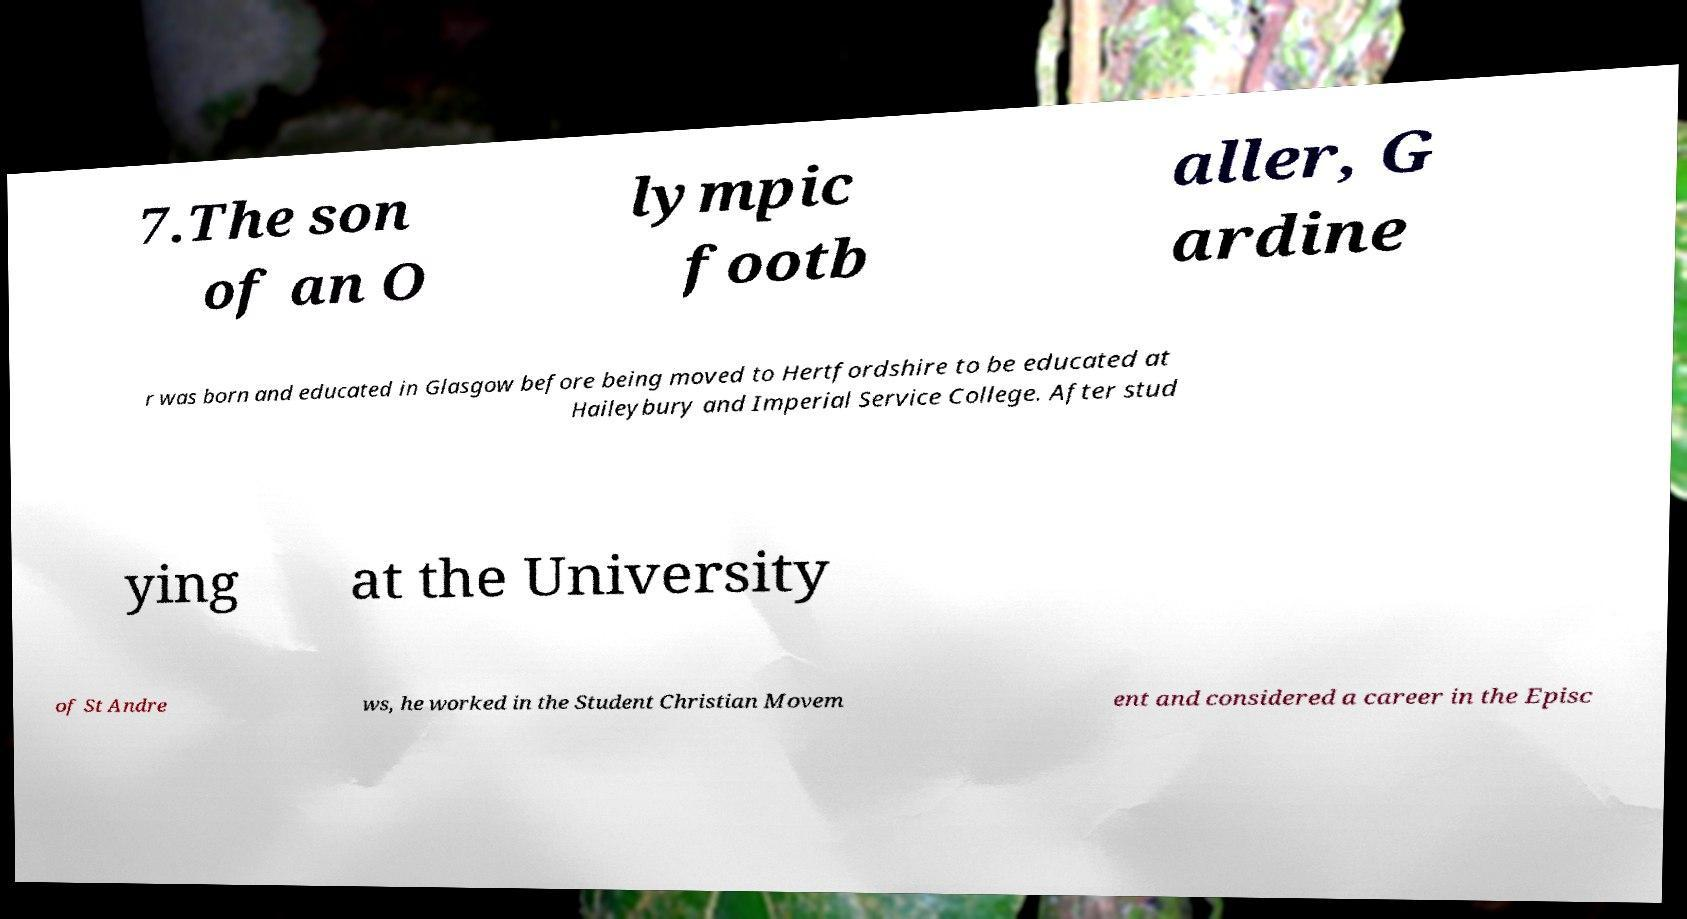Please identify and transcribe the text found in this image. 7.The son of an O lympic footb aller, G ardine r was born and educated in Glasgow before being moved to Hertfordshire to be educated at Haileybury and Imperial Service College. After stud ying at the University of St Andre ws, he worked in the Student Christian Movem ent and considered a career in the Episc 